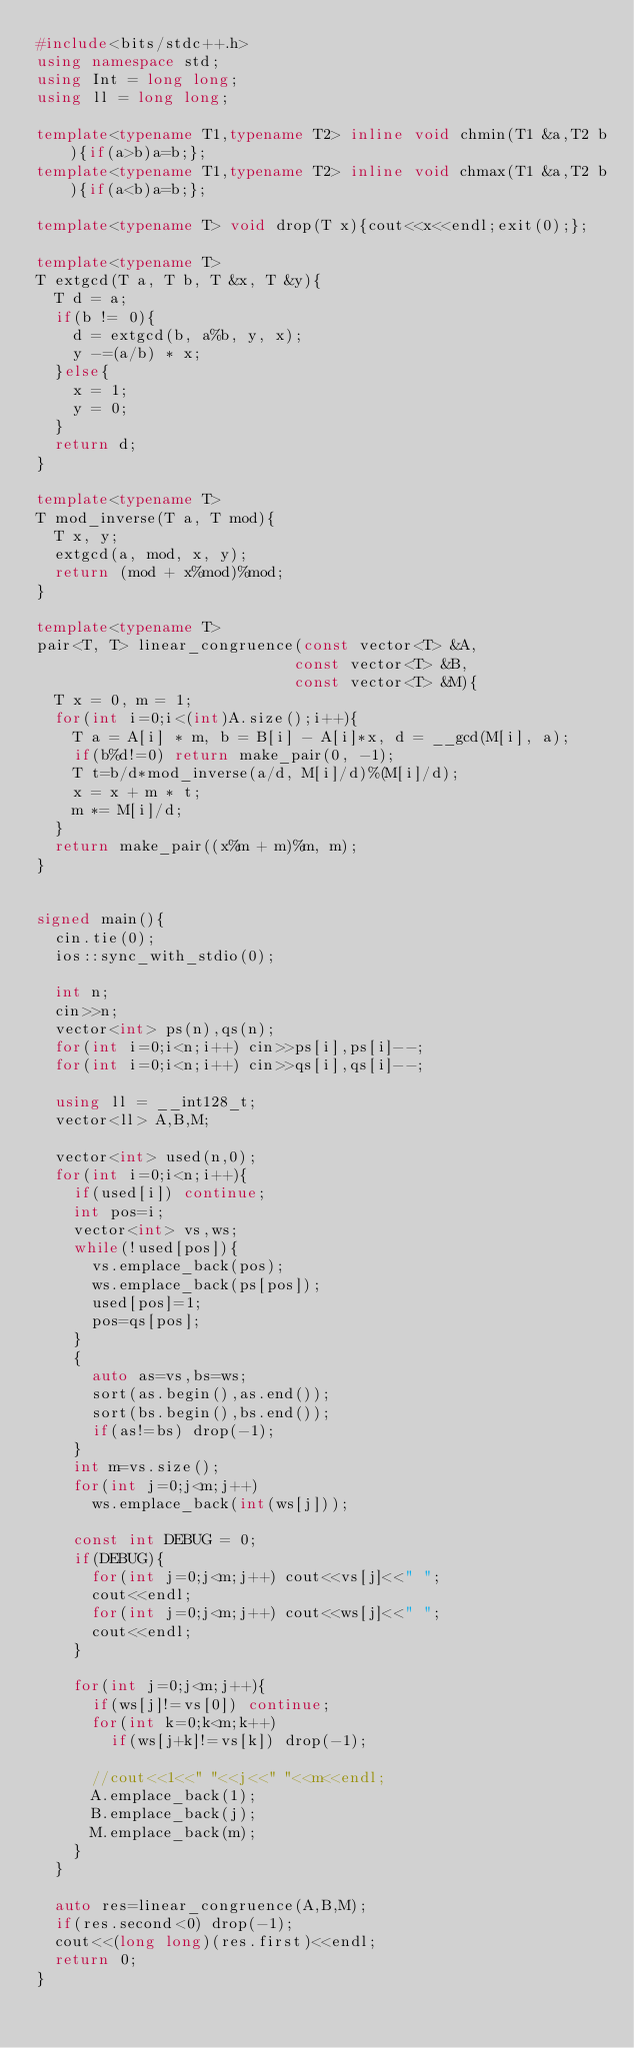Convert code to text. <code><loc_0><loc_0><loc_500><loc_500><_C++_>#include<bits/stdc++.h>
using namespace std;
using Int = long long;
using ll = long long;

template<typename T1,typename T2> inline void chmin(T1 &a,T2 b){if(a>b)a=b;};
template<typename T1,typename T2> inline void chmax(T1 &a,T2 b){if(a<b)a=b;};

template<typename T> void drop(T x){cout<<x<<endl;exit(0);};

template<typename T>
T extgcd(T a, T b, T &x, T &y){
  T d = a;
  if(b != 0){
    d = extgcd(b, a%b, y, x);
    y -=(a/b) * x;
  }else{
    x = 1;
    y = 0;
  }
  return d;
}

template<typename T>
T mod_inverse(T a, T mod){
  T x, y;
  extgcd(a, mod, x, y);
  return (mod + x%mod)%mod;
}

template<typename T>
pair<T, T> linear_congruence(const vector<T> &A,
                            const vector<T> &B,
                            const vector<T> &M){
  T x = 0, m = 1;
  for(int i=0;i<(int)A.size();i++){
    T a = A[i] * m, b = B[i] - A[i]*x, d = __gcd(M[i], a);
    if(b%d!=0) return make_pair(0, -1);
    T t=b/d*mod_inverse(a/d, M[i]/d)%(M[i]/d);
    x = x + m * t;
    m *= M[i]/d;
  }
  return make_pair((x%m + m)%m, m);
}


signed main(){
  cin.tie(0);
  ios::sync_with_stdio(0);

  int n;
  cin>>n;
  vector<int> ps(n),qs(n);
  for(int i=0;i<n;i++) cin>>ps[i],ps[i]--;
  for(int i=0;i<n;i++) cin>>qs[i],qs[i]--;

  using ll = __int128_t;
  vector<ll> A,B,M;

  vector<int> used(n,0);
  for(int i=0;i<n;i++){
    if(used[i]) continue;
    int pos=i;
    vector<int> vs,ws;
    while(!used[pos]){
      vs.emplace_back(pos);
      ws.emplace_back(ps[pos]);
      used[pos]=1;
      pos=qs[pos];
    }
    {
      auto as=vs,bs=ws;
      sort(as.begin(),as.end());
      sort(bs.begin(),bs.end());
      if(as!=bs) drop(-1);
    }
    int m=vs.size();
    for(int j=0;j<m;j++)
      ws.emplace_back(int(ws[j]));

    const int DEBUG = 0;
    if(DEBUG){
      for(int j=0;j<m;j++) cout<<vs[j]<<" ";
      cout<<endl;
      for(int j=0;j<m;j++) cout<<ws[j]<<" ";
      cout<<endl;
    }

    for(int j=0;j<m;j++){
      if(ws[j]!=vs[0]) continue;
      for(int k=0;k<m;k++)
        if(ws[j+k]!=vs[k]) drop(-1);

      //cout<<1<<" "<<j<<" "<<m<<endl;
      A.emplace_back(1);
      B.emplace_back(j);
      M.emplace_back(m);
    }
  }

  auto res=linear_congruence(A,B,M);
  if(res.second<0) drop(-1);
  cout<<(long long)(res.first)<<endl;
  return 0;
}

</code> 